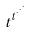Convert formula to latex. <formula><loc_0><loc_0><loc_500><loc_500>t ^ { t ^ { \cdot ^ { \cdot ^ { \cdot } } } }</formula> 